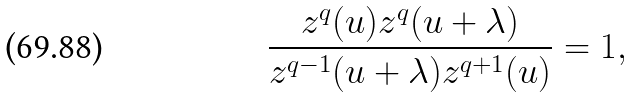Convert formula to latex. <formula><loc_0><loc_0><loc_500><loc_500>\frac { z ^ { q } ( u ) z ^ { q } ( u + \lambda ) } { z ^ { q - 1 } ( u + \lambda ) z ^ { q + 1 } ( u ) } = 1 ,</formula> 